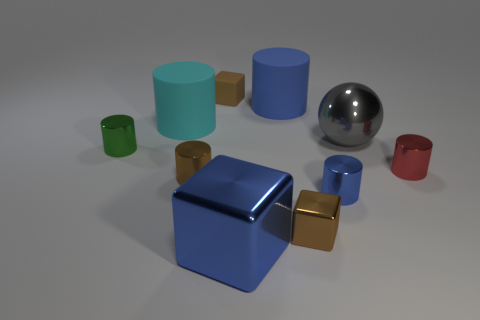Subtract all cyan cylinders. How many cylinders are left? 5 Subtract all blue metal cylinders. How many cylinders are left? 5 Subtract all purple cylinders. Subtract all brown cubes. How many cylinders are left? 6 Subtract all spheres. How many objects are left? 9 Add 9 small cyan matte objects. How many small cyan matte objects exist? 9 Subtract 1 red cylinders. How many objects are left? 9 Subtract all small red metallic cylinders. Subtract all large metal spheres. How many objects are left? 8 Add 6 large blue blocks. How many large blue blocks are left? 7 